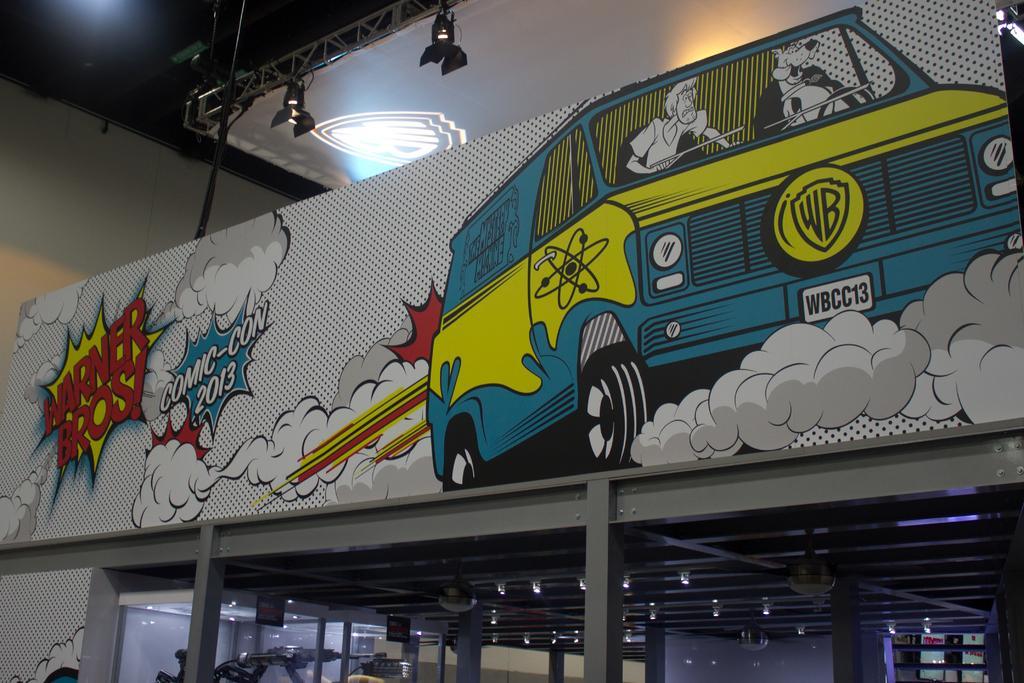Please provide a concise description of this image. In this image there is a roof of the room where we can see there is a painting. 